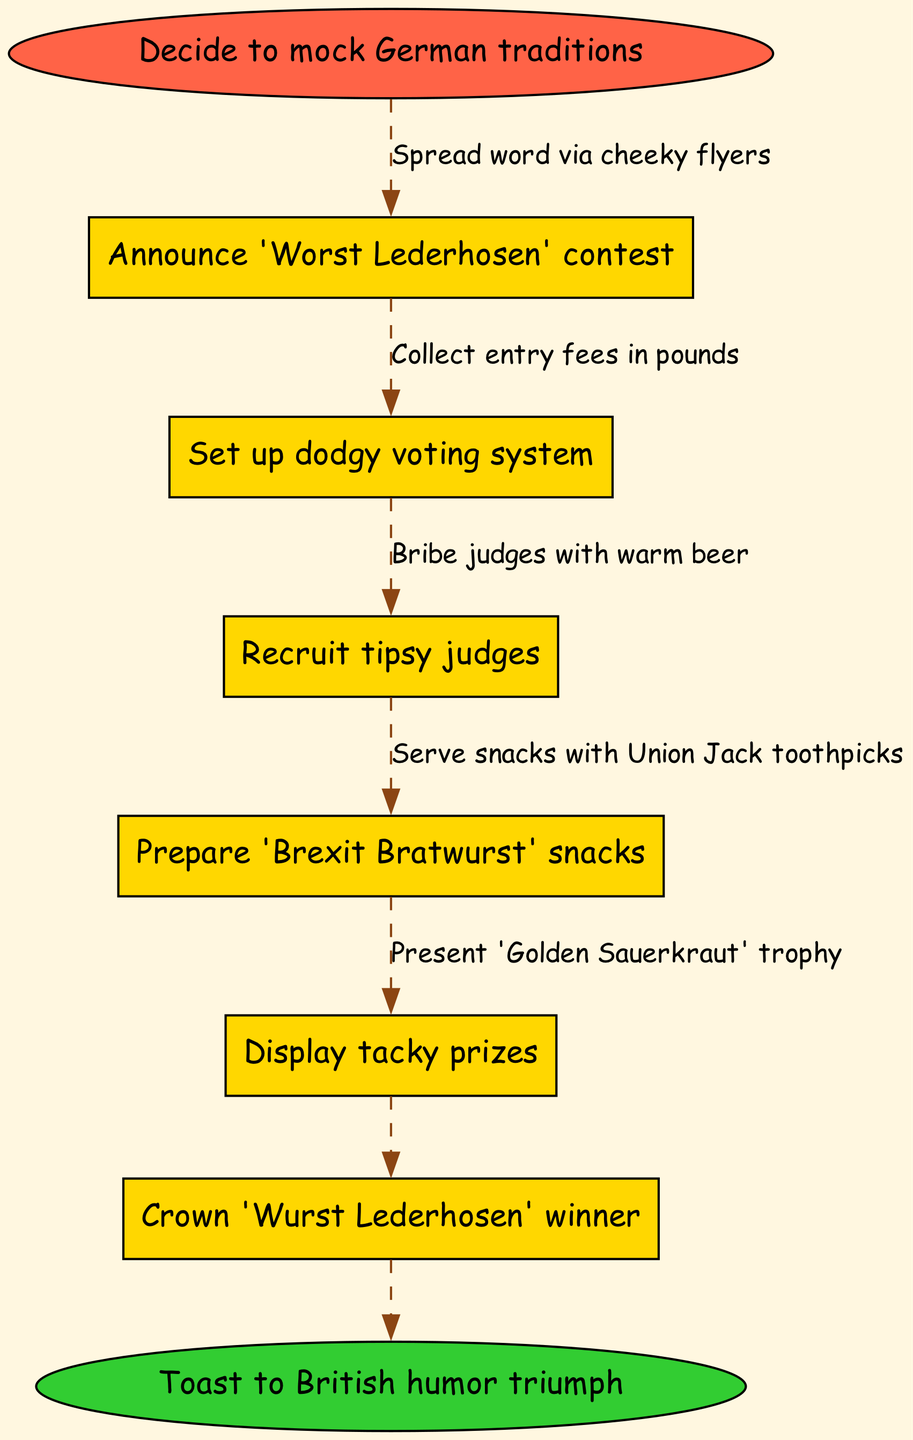What is the starting point of the contest organization? The starting point is explicitly stated as "Decide to mock German traditions," which is the first node in the flowchart. This indicates the initial motivation for the contest.
Answer: Decide to mock German traditions How many nodes are there in the diagram? The diagram includes the start and end points along with the six nodes related to the contest activities. Therefore, the total count of nodes is 8.
Answer: 8 What prize is mentioned for the winner? The diagram specifies that the winner will receive a "Golden Sauerkraut" trophy, which is noted in the final steps of the contest process.
Answer: Golden Sauerkraut What is the last action taken in the contest process? The diagram denotes "Toast to British humor triumph" as the final action, marking the end of the contest process. This action reflects the humorous spirit of the event.
Answer: Toast to British humor triumph What do judges get bribed with? According to the diagram, judges are bribed with "warm beer," indicating a typicalially humorous way to influence the judging process, fitting for a cheeky contest like this.
Answer: warm beer What snack is prepared for the contest? The diagram details that "Brexit Bratwurst" snacks are prepared, adding a playful British twist to the traditional German fare at the contest.
Answer: Brexit Bratwurst How is the voting system described? The voting system is described as "dodgy," implying that it might not be very fair or trustworthy, which fits the lighthearted theme of mocking traditions.
Answer: dodgy voting system What is used to serve snacks? The snacks are served with "Union Jack toothpicks," which further emphasizes the British humor intertwined with the contest activities and decor.
Answer: Union Jack toothpicks 